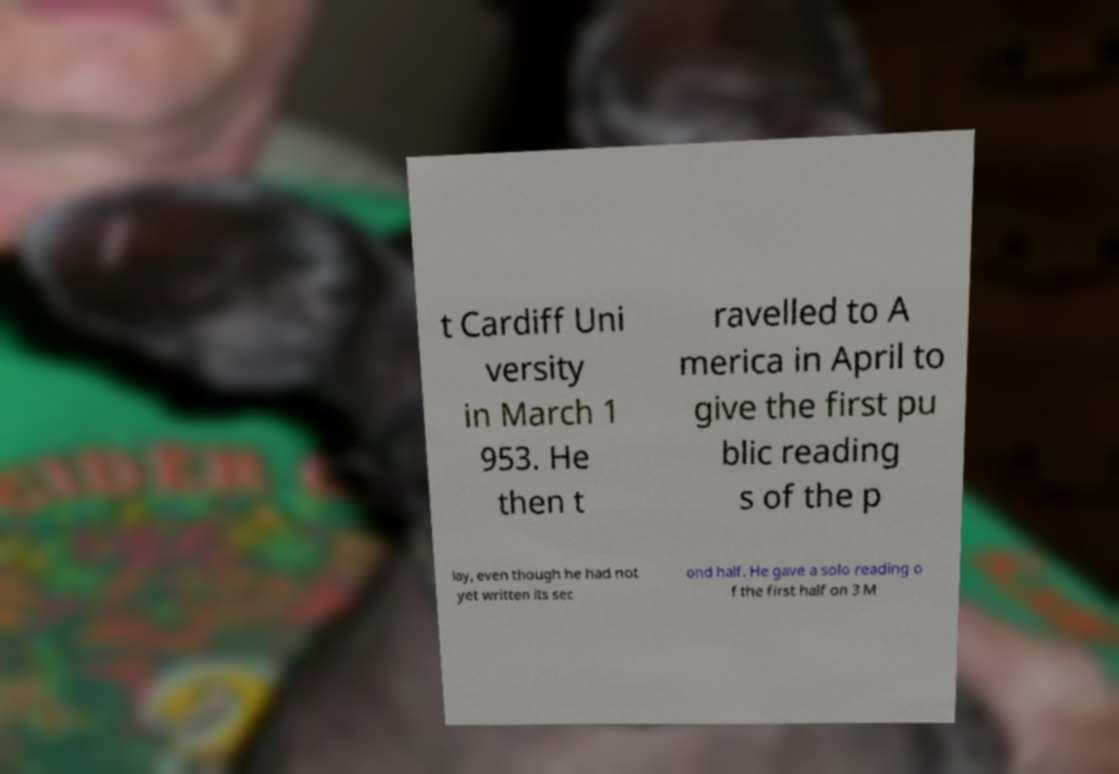I need the written content from this picture converted into text. Can you do that? t Cardiff Uni versity in March 1 953. He then t ravelled to A merica in April to give the first pu blic reading s of the p lay, even though he had not yet written its sec ond half. He gave a solo reading o f the first half on 3 M 